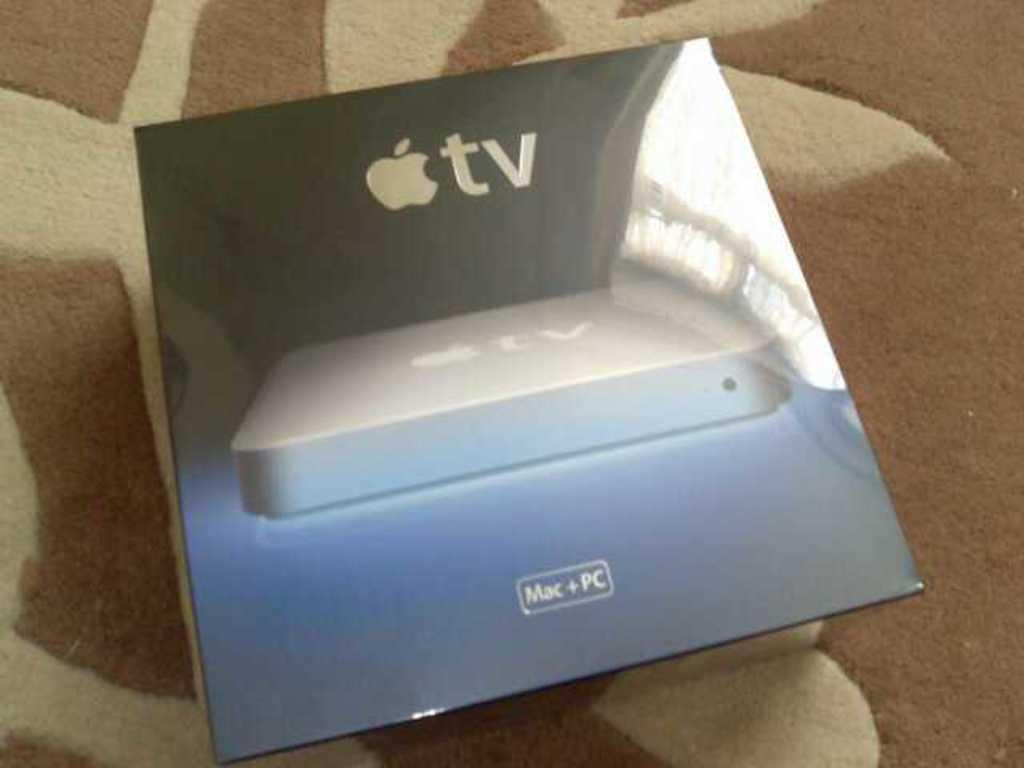<image>
Write a terse but informative summary of the picture. a box for Apple TV reading Mac + PC on a brown and beige run 